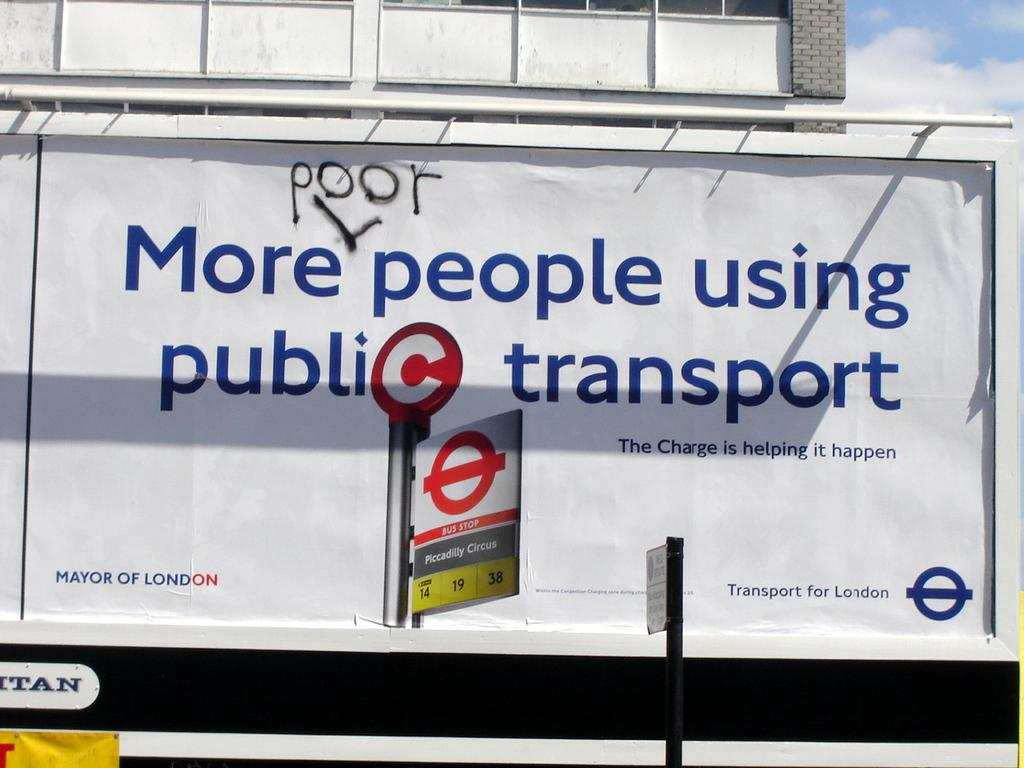<image>
Provide a brief description of the given image. On a billboard sign for public transport the word poor has been spray painted. 